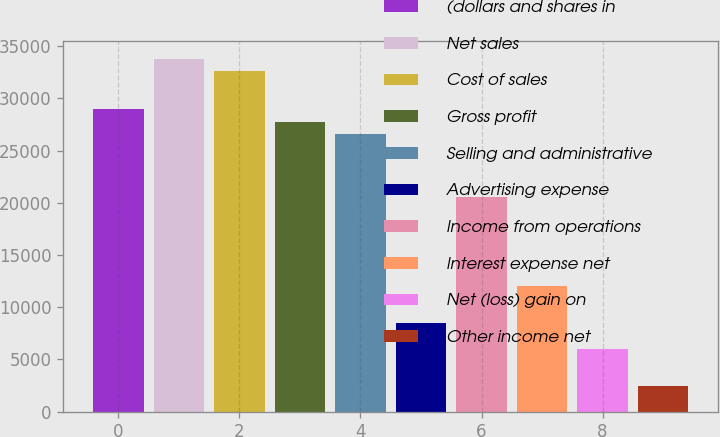<chart> <loc_0><loc_0><loc_500><loc_500><bar_chart><fcel>(dollars and shares in<fcel>Net sales<fcel>Cost of sales<fcel>Gross profit<fcel>Selling and administrative<fcel>Advertising expense<fcel>Income from operations<fcel>Interest expense net<fcel>Net (loss) gain on<fcel>Other income net<nl><fcel>28976.9<fcel>33806.1<fcel>32598.8<fcel>27769.5<fcel>26562.2<fcel>8452.59<fcel>20525.7<fcel>12074.5<fcel>6037.97<fcel>2416.04<nl></chart> 